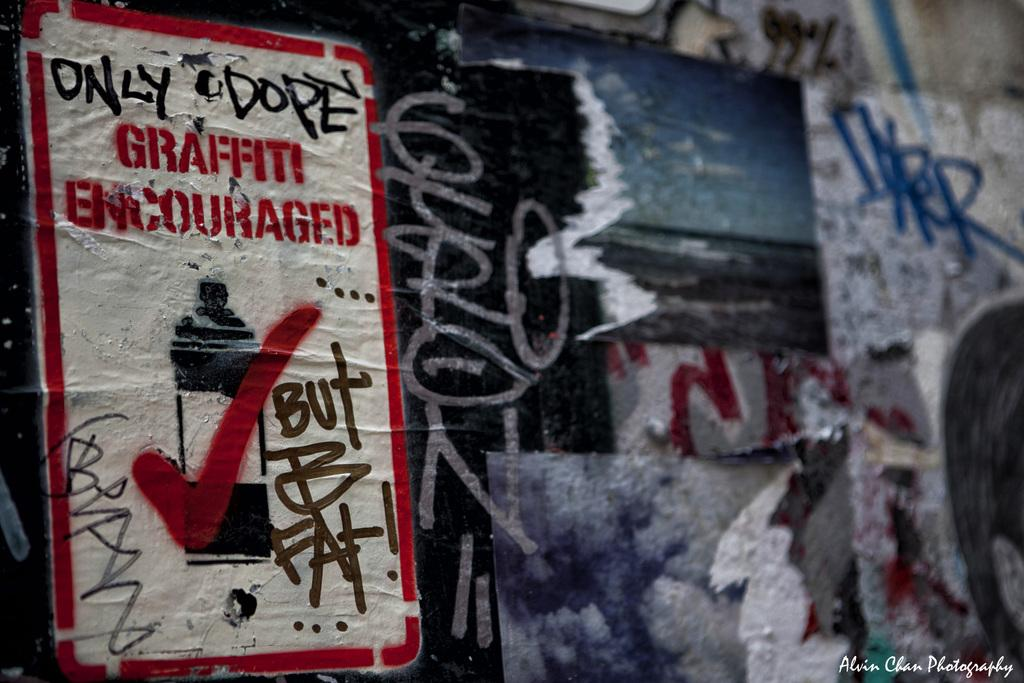<image>
Summarize the visual content of the image. Several tattered posters pasted atop each other with one encouraging graffiti. 